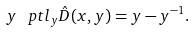Convert formula to latex. <formula><loc_0><loc_0><loc_500><loc_500>y \, \ p t l _ { y } \hat { D } ( x , y ) = y - y ^ { - 1 } .</formula> 